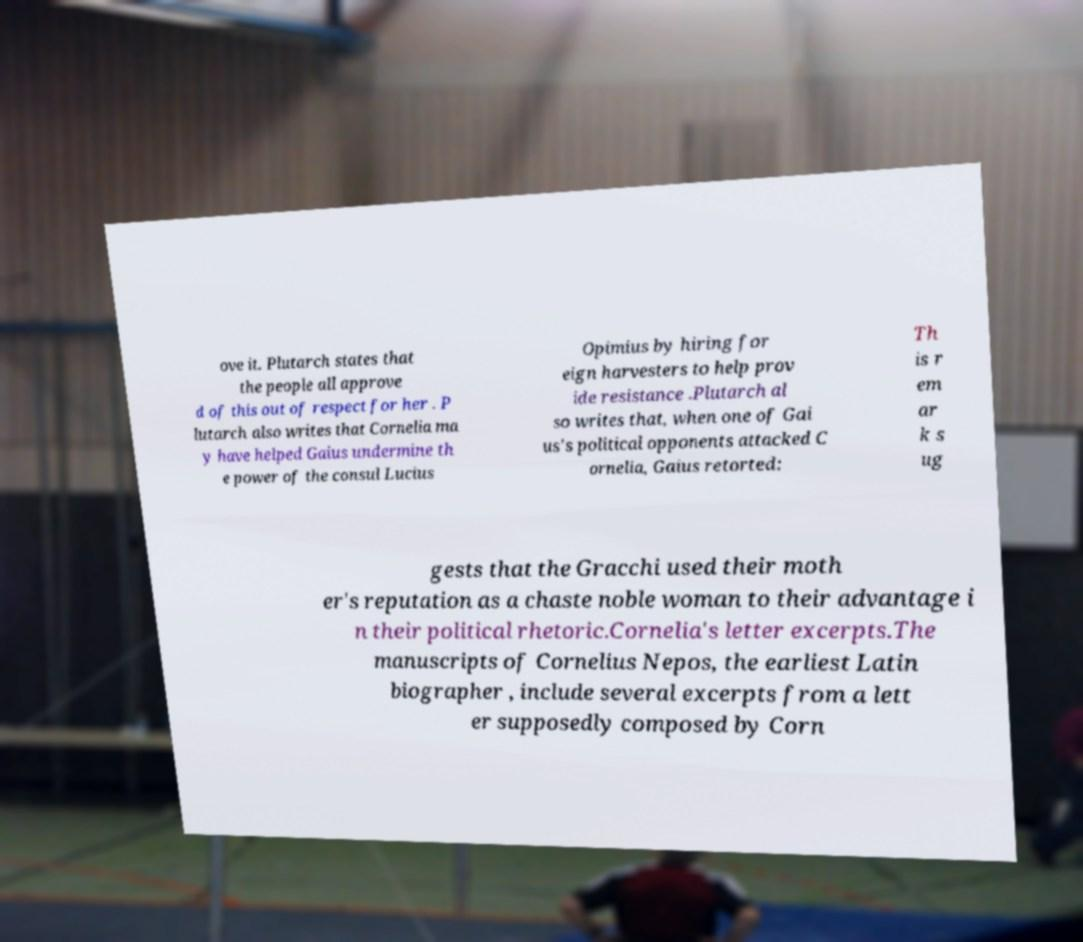Can you accurately transcribe the text from the provided image for me? ove it. Plutarch states that the people all approve d of this out of respect for her . P lutarch also writes that Cornelia ma y have helped Gaius undermine th e power of the consul Lucius Opimius by hiring for eign harvesters to help prov ide resistance .Plutarch al so writes that, when one of Gai us's political opponents attacked C ornelia, Gaius retorted: Th is r em ar k s ug gests that the Gracchi used their moth er's reputation as a chaste noble woman to their advantage i n their political rhetoric.Cornelia's letter excerpts.The manuscripts of Cornelius Nepos, the earliest Latin biographer , include several excerpts from a lett er supposedly composed by Corn 